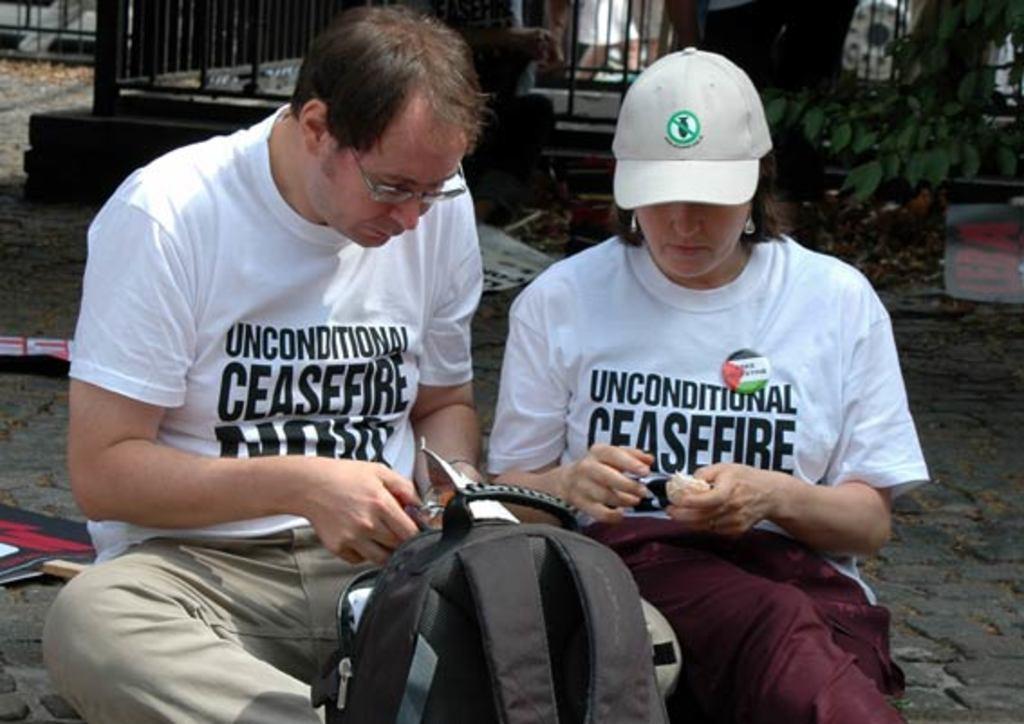Could you give a brief overview of what you see in this image? On the right side of the image a lady is sitting and holding an object and wearing a cap. On the left side of the image a man is sitting and holding an object. At the bottom of the image a bag is there. At the top of the image we can see grills, tree, paper are present. On the right side of the image a road is there. On the left side of the image a board is present. 